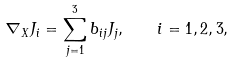<formula> <loc_0><loc_0><loc_500><loc_500>\nabla _ { X } J _ { i } = \sum _ { j = 1 } ^ { 3 } b _ { i j } J _ { j } , \quad i = 1 , 2 , 3 ,</formula> 